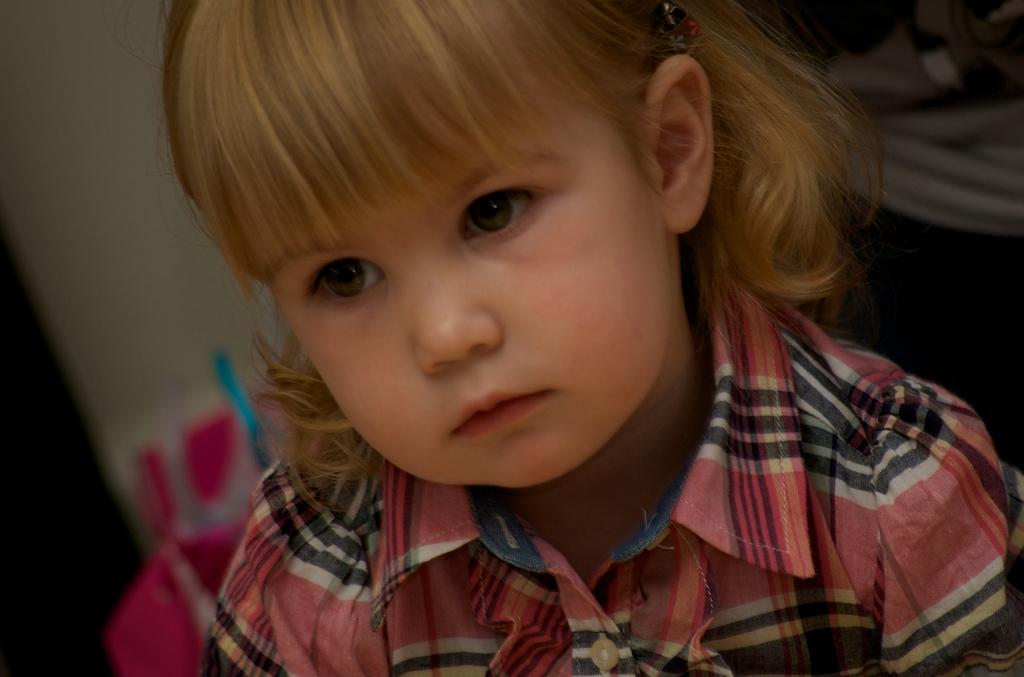Who is the main subject in the image? There is a girl in the image. What type of beast can be seen accompanying the girl in the image? There is no beast present in the image; it only features a girl. 